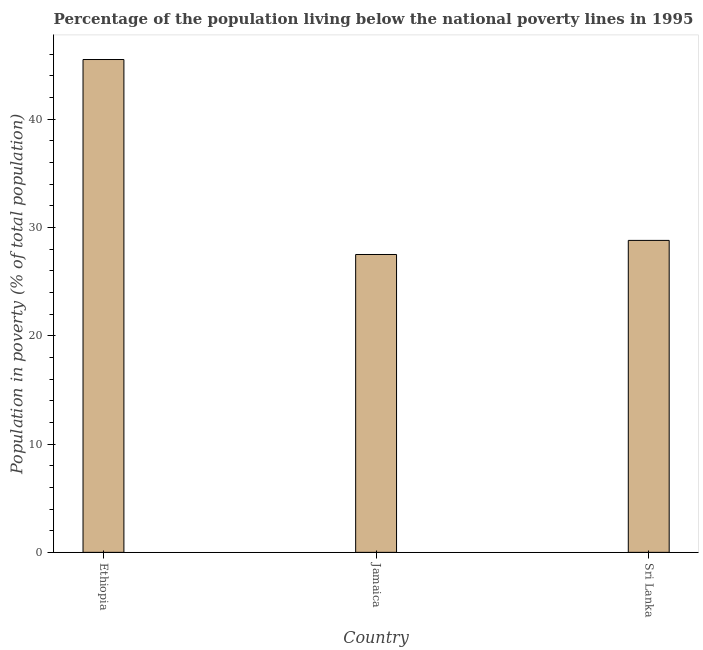Does the graph contain grids?
Keep it short and to the point. No. What is the title of the graph?
Your answer should be compact. Percentage of the population living below the national poverty lines in 1995. What is the label or title of the Y-axis?
Provide a succinct answer. Population in poverty (% of total population). What is the percentage of population living below poverty line in Ethiopia?
Your answer should be compact. 45.5. Across all countries, what is the maximum percentage of population living below poverty line?
Provide a succinct answer. 45.5. In which country was the percentage of population living below poverty line maximum?
Ensure brevity in your answer.  Ethiopia. In which country was the percentage of population living below poverty line minimum?
Offer a very short reply. Jamaica. What is the sum of the percentage of population living below poverty line?
Provide a succinct answer. 101.8. What is the average percentage of population living below poverty line per country?
Your response must be concise. 33.93. What is the median percentage of population living below poverty line?
Give a very brief answer. 28.8. In how many countries, is the percentage of population living below poverty line greater than 24 %?
Ensure brevity in your answer.  3. What is the ratio of the percentage of population living below poverty line in Ethiopia to that in Sri Lanka?
Your answer should be compact. 1.58. Is the percentage of population living below poverty line in Ethiopia less than that in Jamaica?
Give a very brief answer. No. Is the sum of the percentage of population living below poverty line in Jamaica and Sri Lanka greater than the maximum percentage of population living below poverty line across all countries?
Offer a terse response. Yes. What is the difference between the highest and the lowest percentage of population living below poverty line?
Make the answer very short. 18. In how many countries, is the percentage of population living below poverty line greater than the average percentage of population living below poverty line taken over all countries?
Your answer should be compact. 1. How many bars are there?
Give a very brief answer. 3. Are all the bars in the graph horizontal?
Make the answer very short. No. What is the difference between two consecutive major ticks on the Y-axis?
Offer a terse response. 10. Are the values on the major ticks of Y-axis written in scientific E-notation?
Provide a short and direct response. No. What is the Population in poverty (% of total population) in Ethiopia?
Provide a short and direct response. 45.5. What is the Population in poverty (% of total population) of Jamaica?
Your answer should be very brief. 27.5. What is the Population in poverty (% of total population) of Sri Lanka?
Provide a short and direct response. 28.8. What is the difference between the Population in poverty (% of total population) in Ethiopia and Sri Lanka?
Provide a short and direct response. 16.7. What is the ratio of the Population in poverty (% of total population) in Ethiopia to that in Jamaica?
Your answer should be compact. 1.66. What is the ratio of the Population in poverty (% of total population) in Ethiopia to that in Sri Lanka?
Your answer should be very brief. 1.58. What is the ratio of the Population in poverty (% of total population) in Jamaica to that in Sri Lanka?
Offer a terse response. 0.95. 